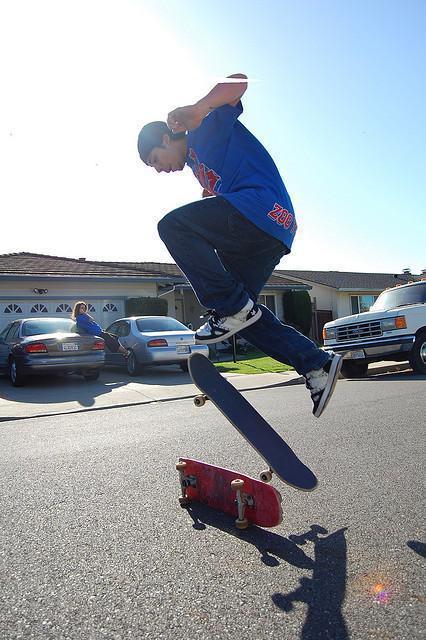How many feet does the skateboard have touching the skateboard?
Give a very brief answer. 0. How many cars are there?
Give a very brief answer. 2. How many skateboards are in the picture?
Give a very brief answer. 2. How many benches are there?
Give a very brief answer. 0. 